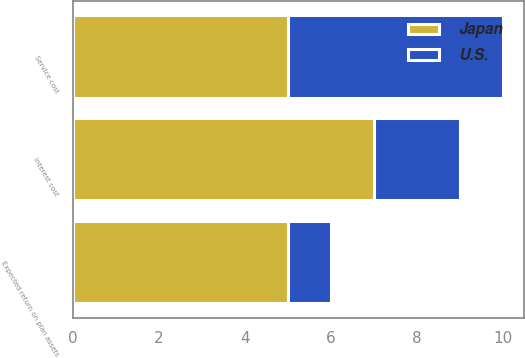Convert chart to OTSL. <chart><loc_0><loc_0><loc_500><loc_500><stacked_bar_chart><ecel><fcel>Service cost<fcel>Interest cost<fcel>Expected return on plan assets<nl><fcel>U.S.<fcel>5<fcel>2<fcel>1<nl><fcel>Japan<fcel>5<fcel>7<fcel>5<nl></chart> 